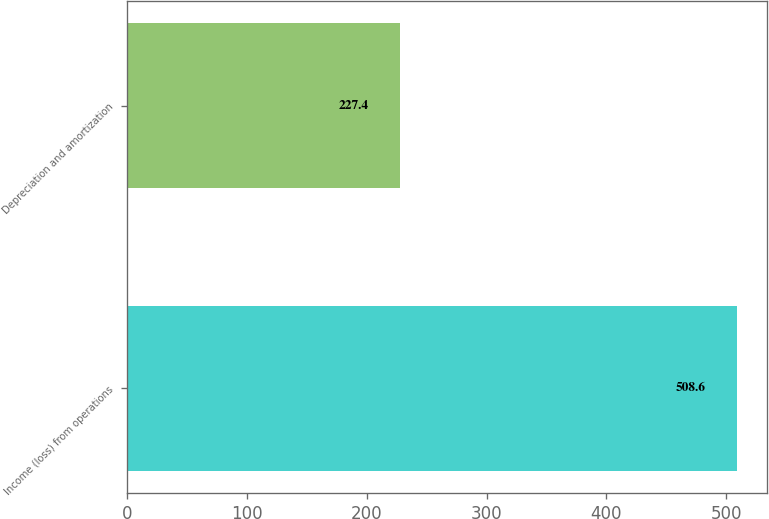Convert chart to OTSL. <chart><loc_0><loc_0><loc_500><loc_500><bar_chart><fcel>Income (loss) from operations<fcel>Depreciation and amortization<nl><fcel>508.6<fcel>227.4<nl></chart> 